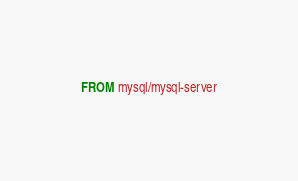<code> <loc_0><loc_0><loc_500><loc_500><_Dockerfile_>FROM mysql/mysql-server
</code> 